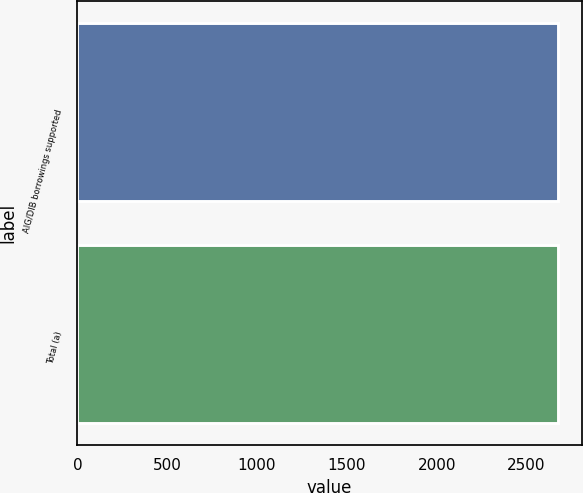Convert chart to OTSL. <chart><loc_0><loc_0><loc_500><loc_500><bar_chart><fcel>AIG/DIB borrowings supported<fcel>Total (a)<nl><fcel>2674<fcel>2675<nl></chart> 